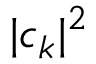<formula> <loc_0><loc_0><loc_500><loc_500>| c _ { k } | ^ { 2 }</formula> 